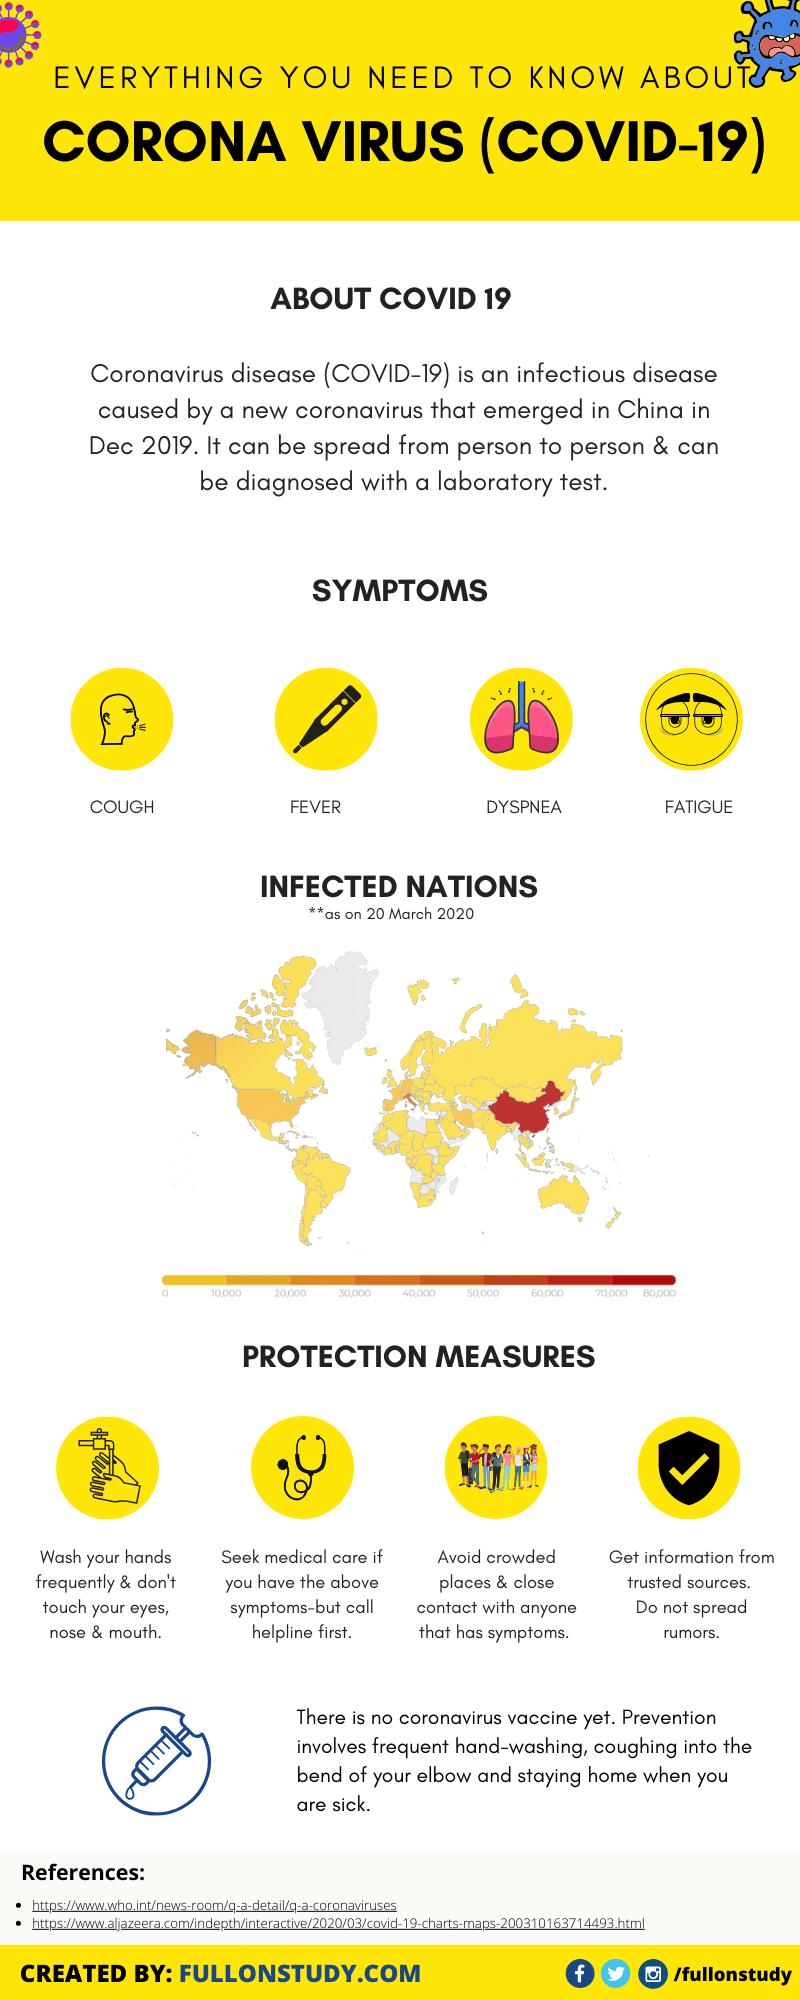List a handful of essential elements in this visual. The symptoms of COVID-19 beyond coughing and fatigue include fever and difficulty breathing. 